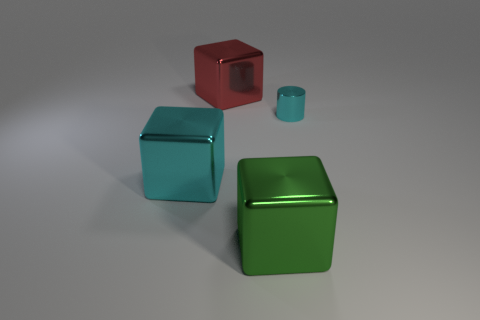Is there any other thing that is the same size as the metal cylinder?
Offer a very short reply. No. Are there any cyan objects that have the same size as the red thing?
Your answer should be very brief. Yes. What is the material of the cube that is behind the big block that is on the left side of the large red cube?
Ensure brevity in your answer.  Metal. What number of other things have the same color as the tiny object?
Keep it short and to the point. 1. What shape is the tiny cyan thing that is the same material as the red cube?
Provide a succinct answer. Cylinder. There is a metallic cube behind the large cyan metallic cube; what size is it?
Keep it short and to the point. Large. Are there an equal number of tiny cylinders left of the cyan metal block and red metallic cubes that are right of the red shiny cube?
Offer a very short reply. Yes. There is a metallic block that is behind the cyan thing on the left side of the metallic object right of the big green thing; what is its color?
Offer a very short reply. Red. What number of metal things are in front of the red cube and on the right side of the cyan metal cube?
Provide a short and direct response. 2. Is the color of the small shiny cylinder right of the green metal thing the same as the big block that is left of the big red object?
Your response must be concise. Yes. 